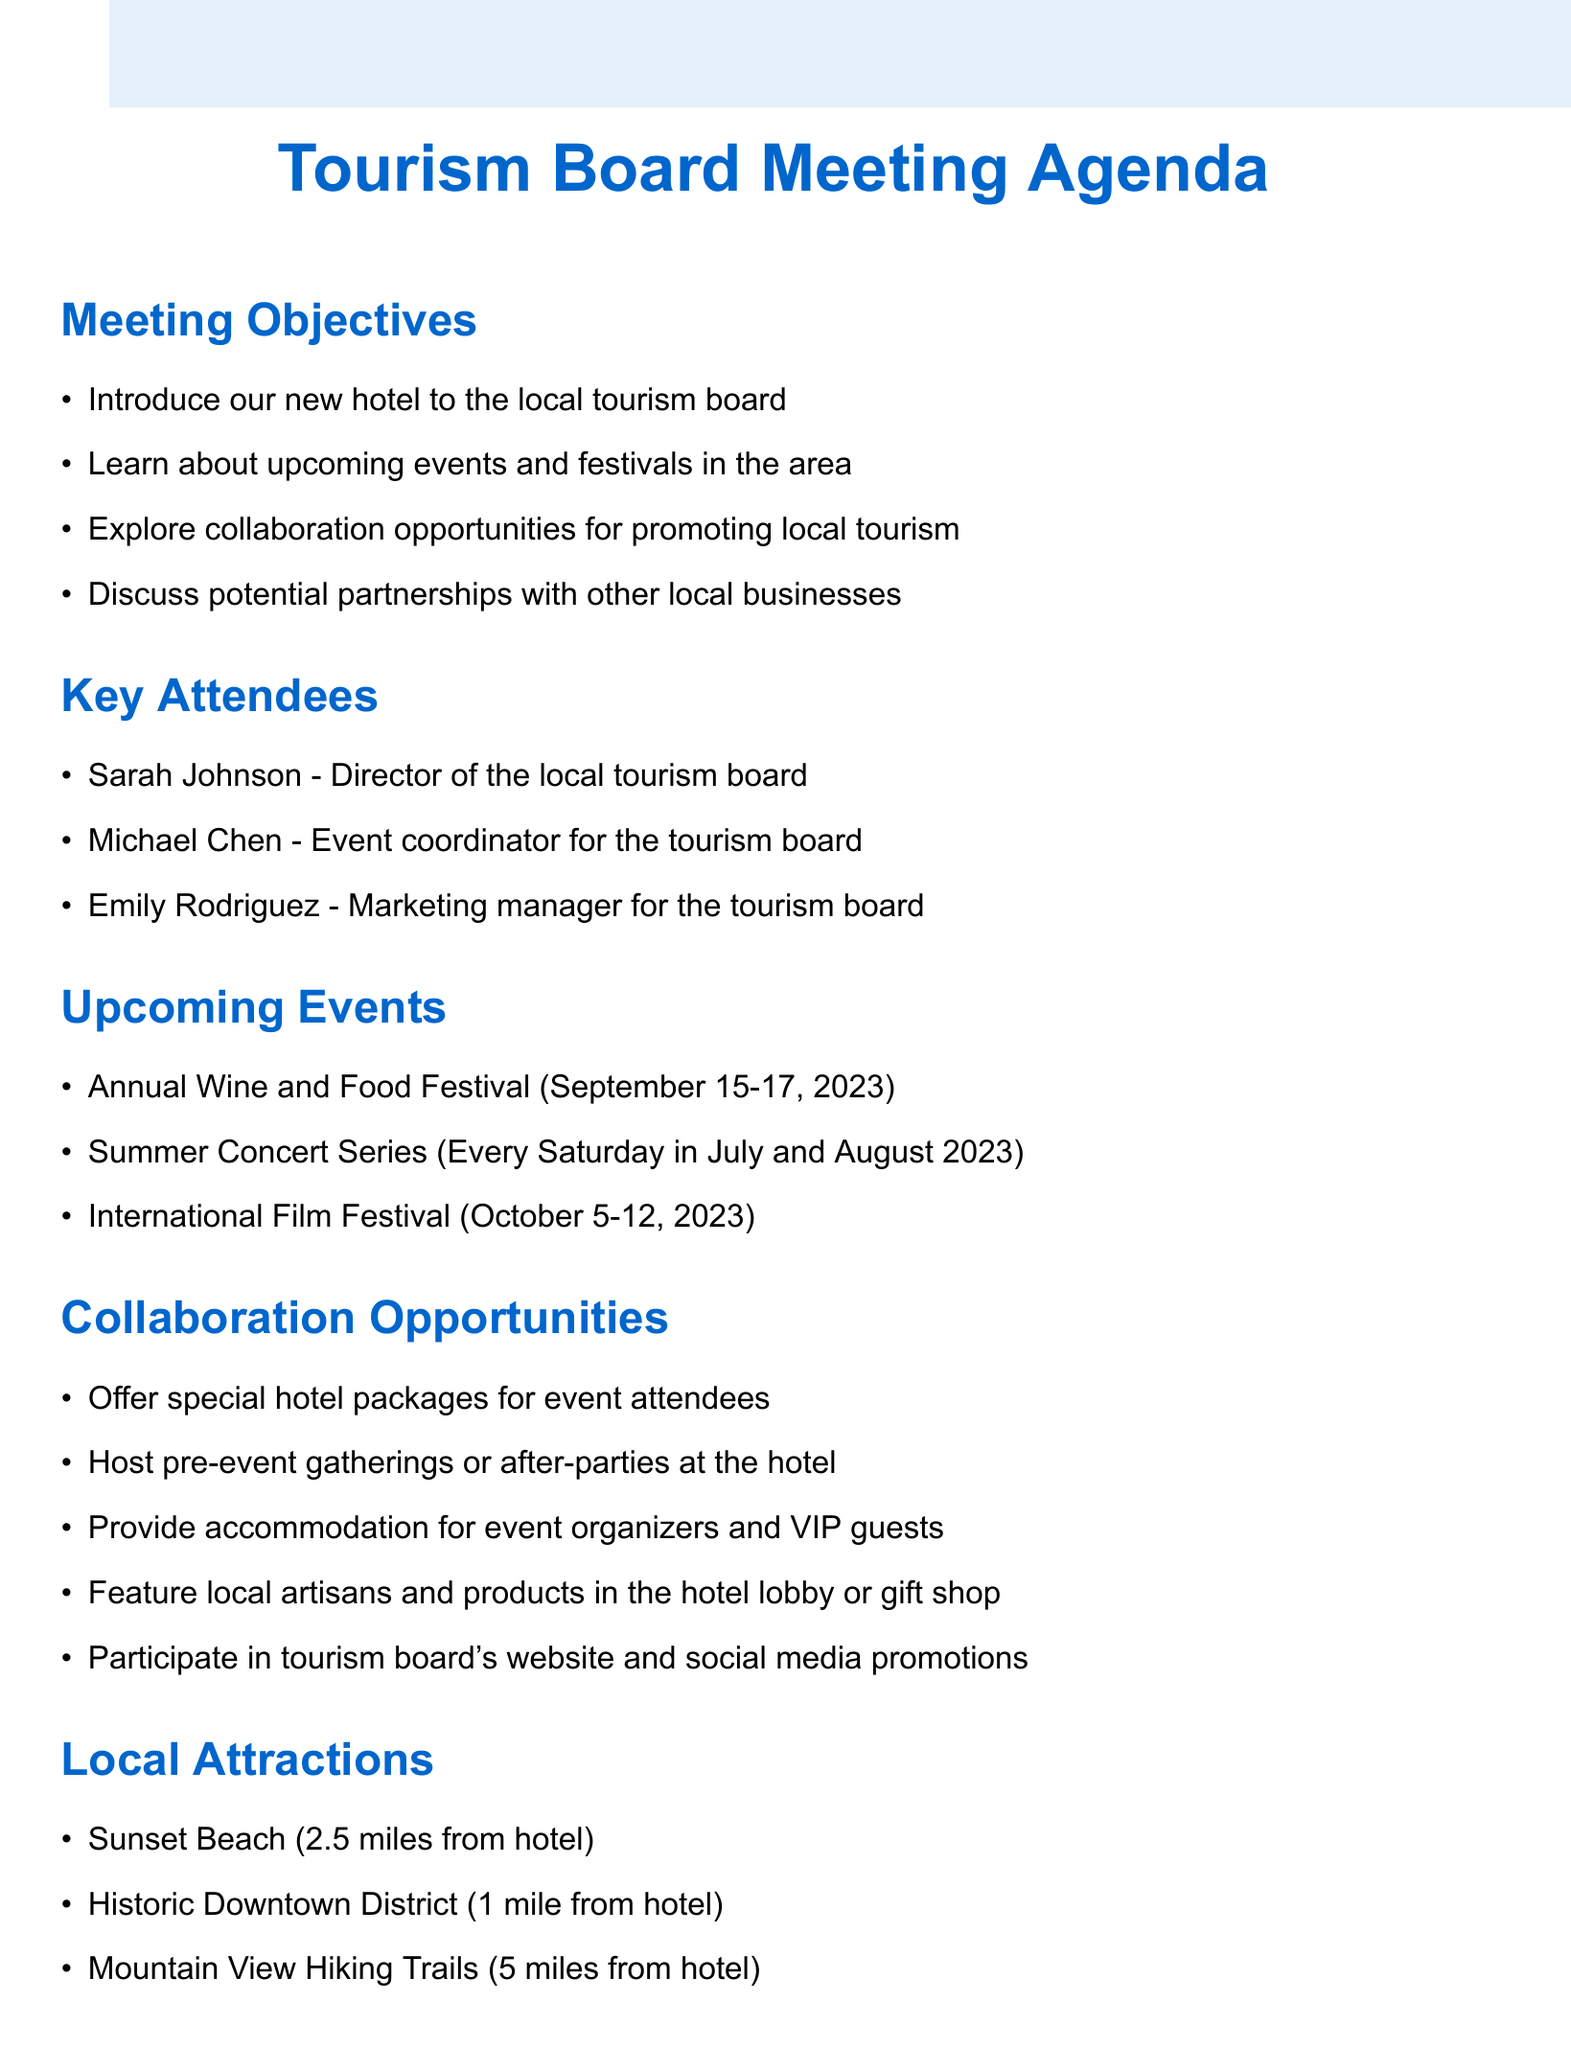what is the name of the tourism board director? The document lists Sarah Johnson as the Director of the local tourism board under the key attendees section.
Answer: Sarah Johnson when is the International Film Festival scheduled? The document specifies that the International Film Festival is scheduled for October 5-12, 2023.
Answer: October 5-12, 2023 how many attendees are expected at the Annual Wine and Food Festival? The expected attendance for the Annual Wine and Food Festival is mentioned as 10000 in the upcoming events section.
Answer: 10000 what collaboration opportunity involves hosting events at the hotel? One of the collaboration opportunities mentioned is to "Host pre-event gatherings or after-parties at the hotel."
Answer: Host pre-event gatherings or after-parties at the hotel which local attraction is 1 mile from the hotel? The Historic Downtown District is noted as being 1 mile from the hotel in the local attractions section.
Answer: Historic Downtown District what marketing question should be asked to the tourism board? One of the proposed questions for the tourism board is "What marketing channels have been most effective for promoting local businesses?"
Answer: What marketing channels have been most effective for promoting local businesses? how far is Sunset Beach from the hotel? The document states that Sunset Beach is located 2.5 miles from the hotel.
Answer: 2.5 miles what type of cuisine does the hotel's in-house restaurant feature? The in-house restaurant at the hotel features local cuisine as mentioned under unique selling points.
Answer: local cuisine 